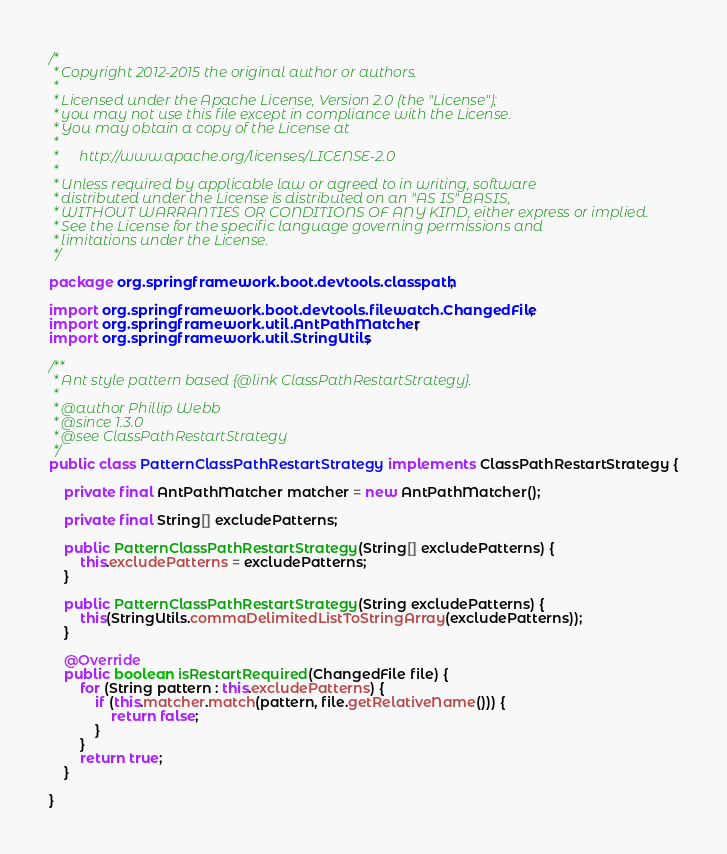<code> <loc_0><loc_0><loc_500><loc_500><_Java_>/*
 * Copyright 2012-2015 the original author or authors.
 *
 * Licensed under the Apache License, Version 2.0 (the "License");
 * you may not use this file except in compliance with the License.
 * You may obtain a copy of the License at
 *
 *      http://www.apache.org/licenses/LICENSE-2.0
 *
 * Unless required by applicable law or agreed to in writing, software
 * distributed under the License is distributed on an "AS IS" BASIS,
 * WITHOUT WARRANTIES OR CONDITIONS OF ANY KIND, either express or implied.
 * See the License for the specific language governing permissions and
 * limitations under the License.
 */

package org.springframework.boot.devtools.classpath;

import org.springframework.boot.devtools.filewatch.ChangedFile;
import org.springframework.util.AntPathMatcher;
import org.springframework.util.StringUtils;

/**
 * Ant style pattern based {@link ClassPathRestartStrategy}.
 *
 * @author Phillip Webb
 * @since 1.3.0
 * @see ClassPathRestartStrategy
 */
public class PatternClassPathRestartStrategy implements ClassPathRestartStrategy {

	private final AntPathMatcher matcher = new AntPathMatcher();

	private final String[] excludePatterns;

	public PatternClassPathRestartStrategy(String[] excludePatterns) {
		this.excludePatterns = excludePatterns;
	}

	public PatternClassPathRestartStrategy(String excludePatterns) {
		this(StringUtils.commaDelimitedListToStringArray(excludePatterns));
	}

	@Override
	public boolean isRestartRequired(ChangedFile file) {
		for (String pattern : this.excludePatterns) {
			if (this.matcher.match(pattern, file.getRelativeName())) {
				return false;
			}
		}
		return true;
	}

}
</code> 